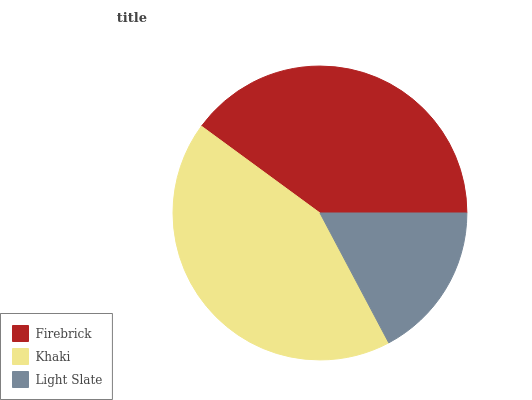Is Light Slate the minimum?
Answer yes or no. Yes. Is Khaki the maximum?
Answer yes or no. Yes. Is Khaki the minimum?
Answer yes or no. No. Is Light Slate the maximum?
Answer yes or no. No. Is Khaki greater than Light Slate?
Answer yes or no. Yes. Is Light Slate less than Khaki?
Answer yes or no. Yes. Is Light Slate greater than Khaki?
Answer yes or no. No. Is Khaki less than Light Slate?
Answer yes or no. No. Is Firebrick the high median?
Answer yes or no. Yes. Is Firebrick the low median?
Answer yes or no. Yes. Is Light Slate the high median?
Answer yes or no. No. Is Khaki the low median?
Answer yes or no. No. 